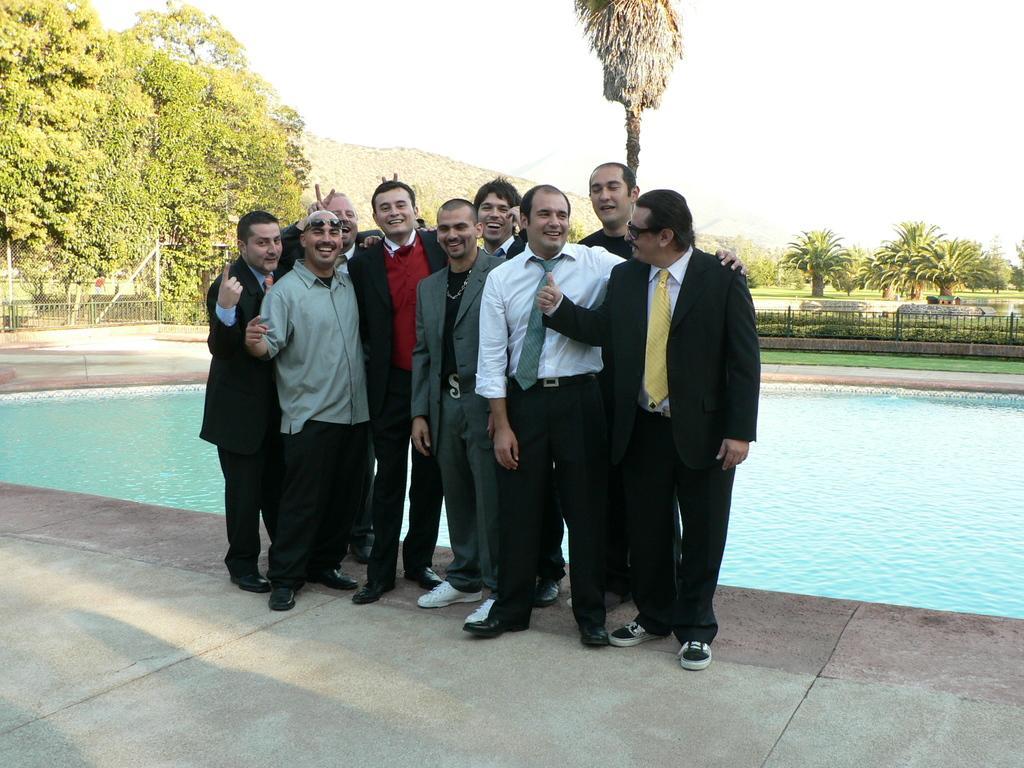Could you give a brief overview of what you see in this image? In the image there are few men in suits standing in front of pool, they all smiling, in the back there are many trees all over place on grassland and above its sky. 